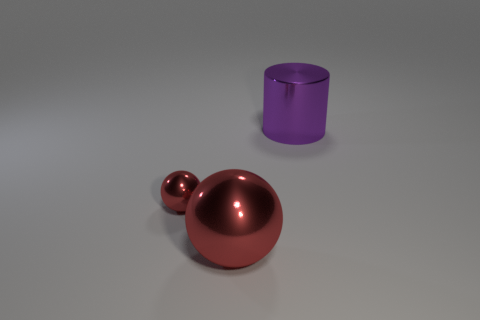There is a big thing that is the same color as the tiny metallic thing; what is it made of?
Provide a short and direct response. Metal. What number of objects are behind the large red object and in front of the big purple metallic thing?
Provide a short and direct response. 1. What is the size of the red metal ball in front of the sphere that is behind the large red shiny object?
Offer a very short reply. Large. Are there fewer purple cylinders in front of the big cylinder than large metal cylinders that are behind the big shiny sphere?
Make the answer very short. Yes. There is a thing that is on the left side of the large red metallic object; is its color the same as the large metallic object that is on the left side of the big metal cylinder?
Your response must be concise. Yes. Is there a large brown matte cube?
Provide a succinct answer. No. There is a large red thing that is made of the same material as the large purple thing; what is its shape?
Make the answer very short. Sphere. Is the shape of the large red thing the same as the shiny thing behind the tiny red shiny sphere?
Offer a terse response. No. There is a red object that is behind the big metallic object left of the purple object; what is its material?
Your response must be concise. Metal. What number of other things are there of the same shape as the tiny red metallic object?
Ensure brevity in your answer.  1. 